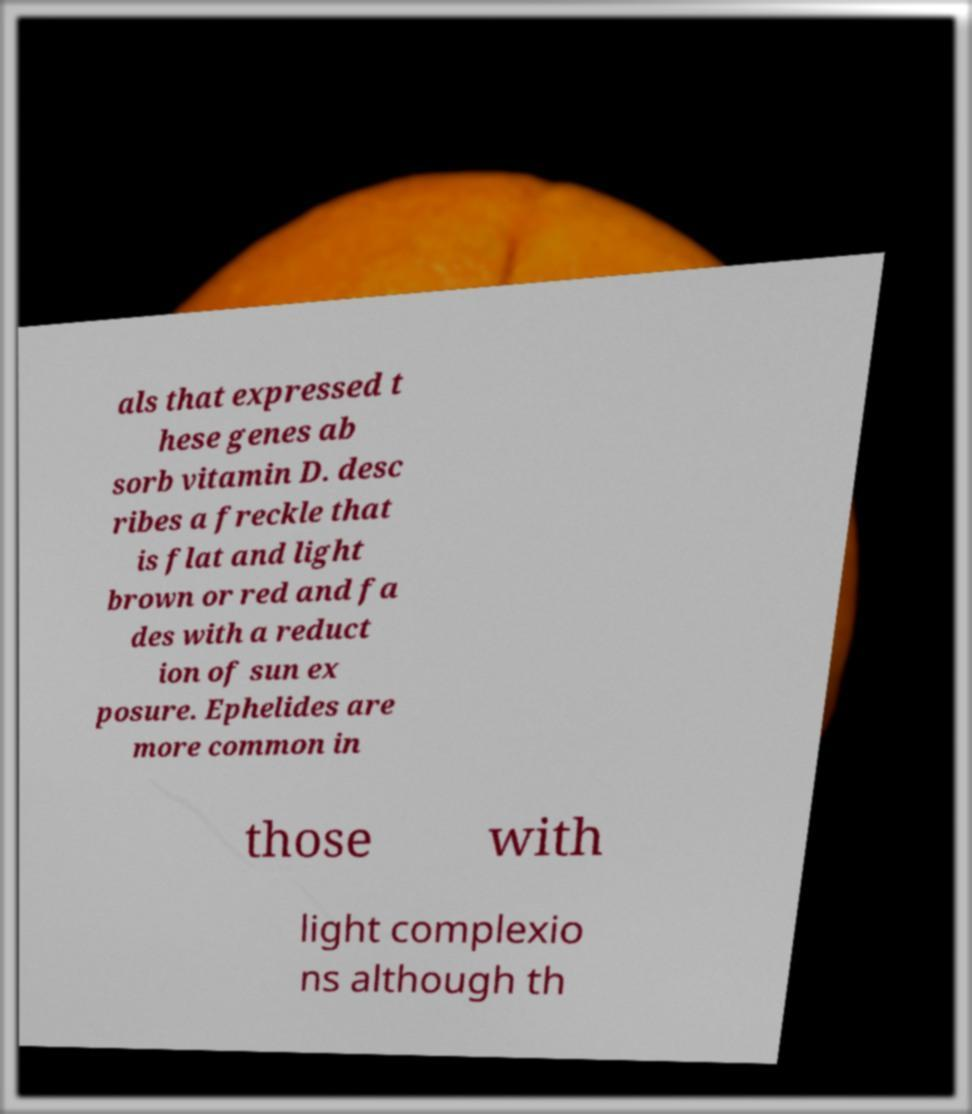Please identify and transcribe the text found in this image. als that expressed t hese genes ab sorb vitamin D. desc ribes a freckle that is flat and light brown or red and fa des with a reduct ion of sun ex posure. Ephelides are more common in those with light complexio ns although th 